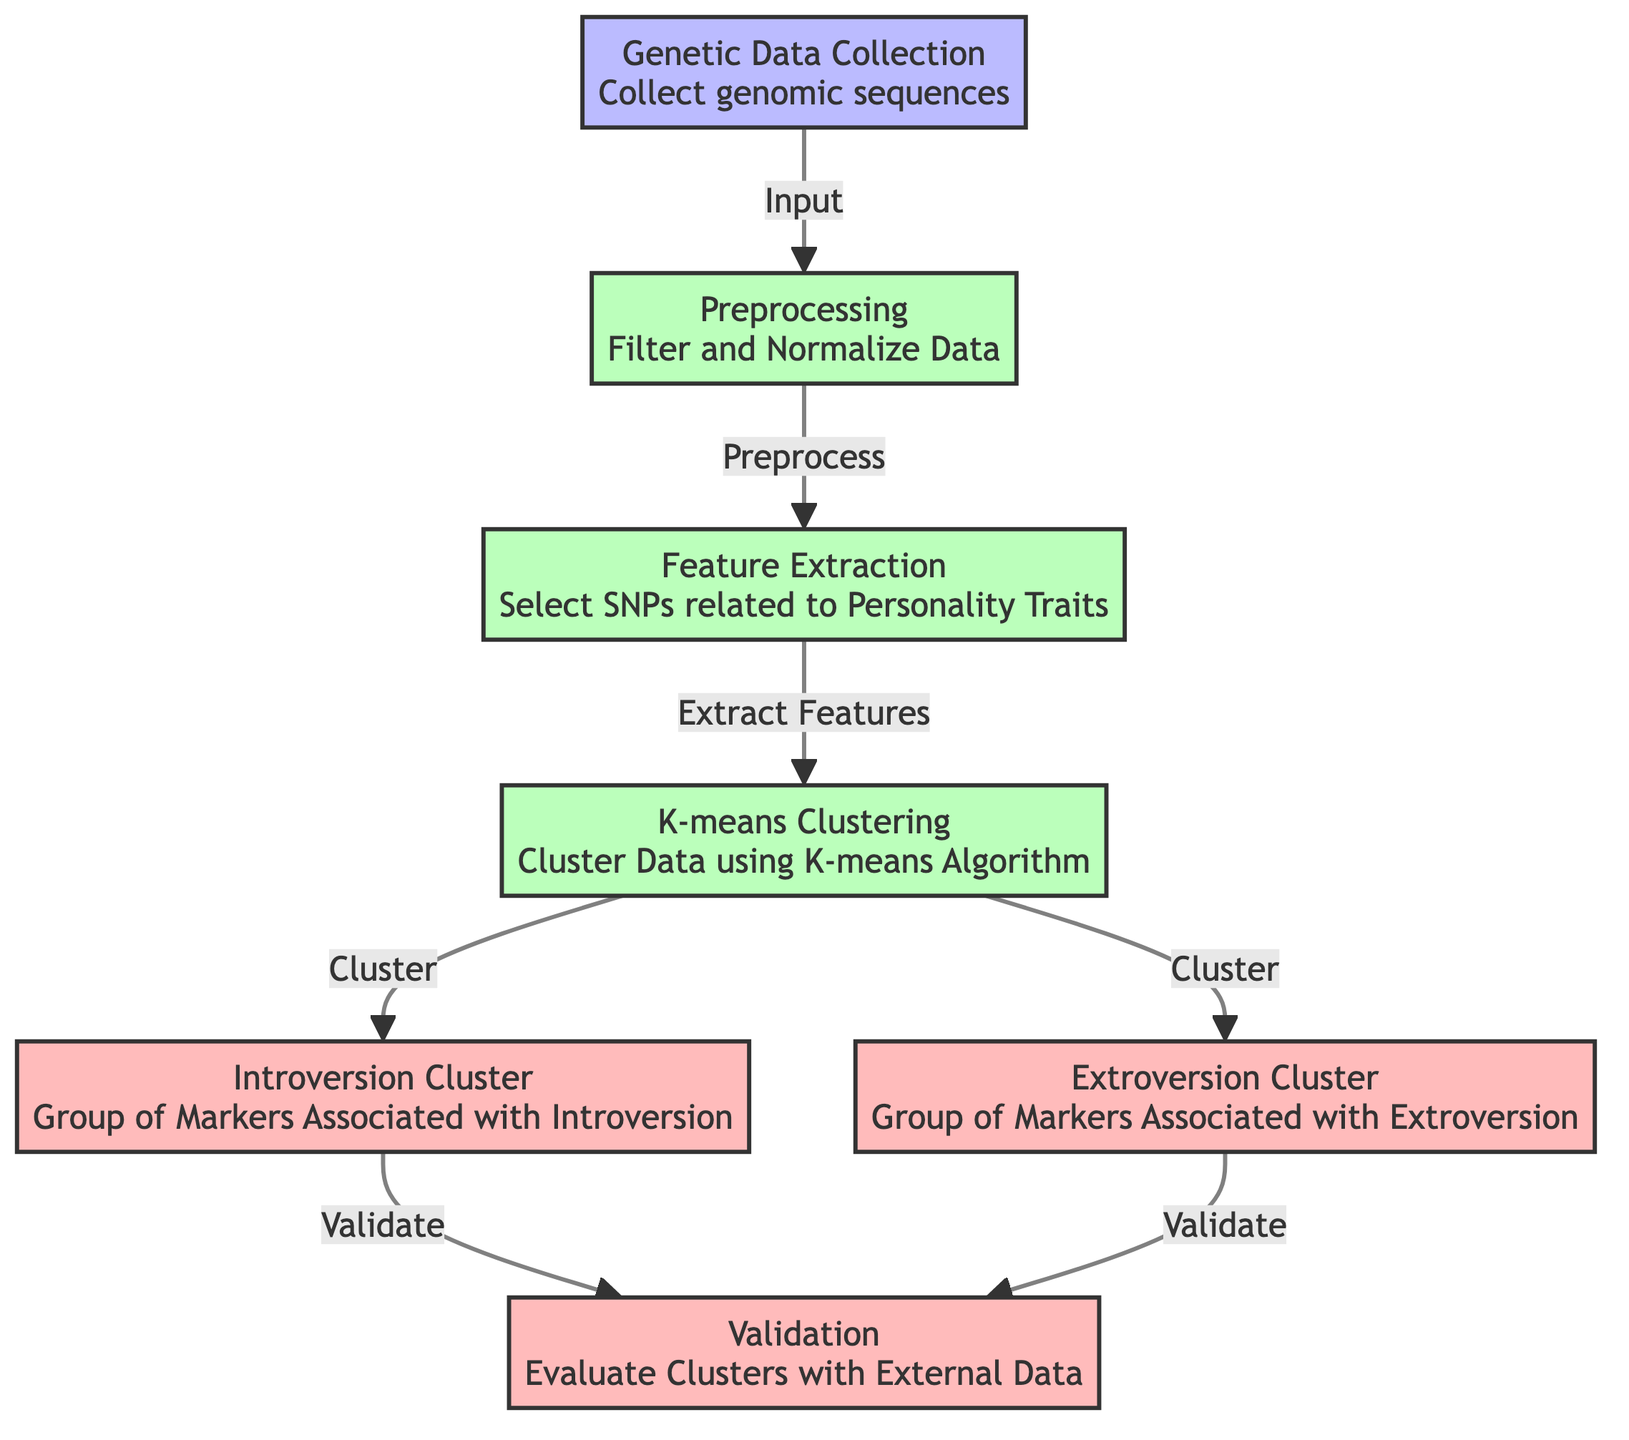What is the first step in the diagram? The diagram shows that the first step involves "Genetic Data Collection", which entails collecting genomic sequences as the input for further processing.
Answer: Genetic Data Collection How many output clusters are generated in the K-means clustering process? The diagram indicates that there are two output clusters generated from the K-means clustering: one for Introversion and another for Extroversion.
Answer: Two What type of data is processed in the second step? The second step in the diagram focuses on "Preprocessing", which involves filtering and normalizing the genetic data collected in the first step before feature extraction.
Answer: Genetic data Which step follows feature extraction? After the feature extraction, which selects SNPs related to personality traits, the next step is K-means clustering, where the data is clustered based on these extracted features.
Answer: K-means Clustering What is validated with external data in the final step? In the final step, both the Introversion and Extroversion clusters are validated with external data to evaluate the effectiveness of the clustering performed.
Answer: Clusters How does the flow from preprocessing to feature extraction appear? The flowchart shows a direct arrow leading from "Preprocessing" to "Feature Extraction", indicating that processing steps are sequential and that the output of preprocessing is necessary for feature extraction.
Answer: Direct Arrow Which genetic markers are associated with extroversion? The diagram indicates that the "Extroversion Cluster" is the output group of markers that correspond to extroverted traits identified through the K-means clustering process.
Answer: Extroversion Cluster 